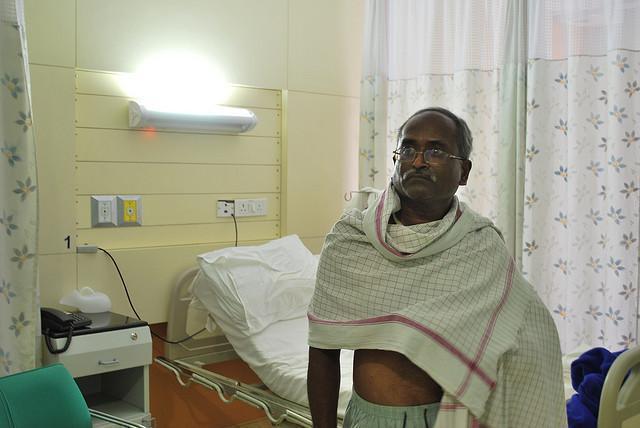This man looks most similar to what historical figure?
Choose the right answer and clarify with the format: 'Answer: answer
Rationale: rationale.'
Options: Mahatma gandhi, date masamune, cesare borgia, benito mussolini. Answer: mahatma gandhi.
Rationale: The man is like gandhi. 